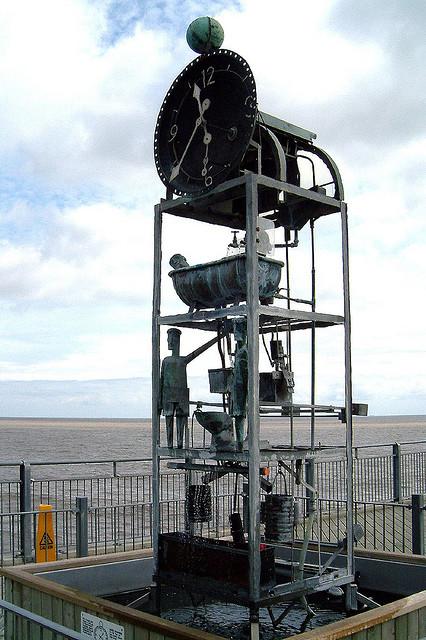What time is it?
Keep it brief. Daytime. Are there people in the picture?
Keep it brief. No. What is underneath the clock?
Keep it brief. Bathtub. 